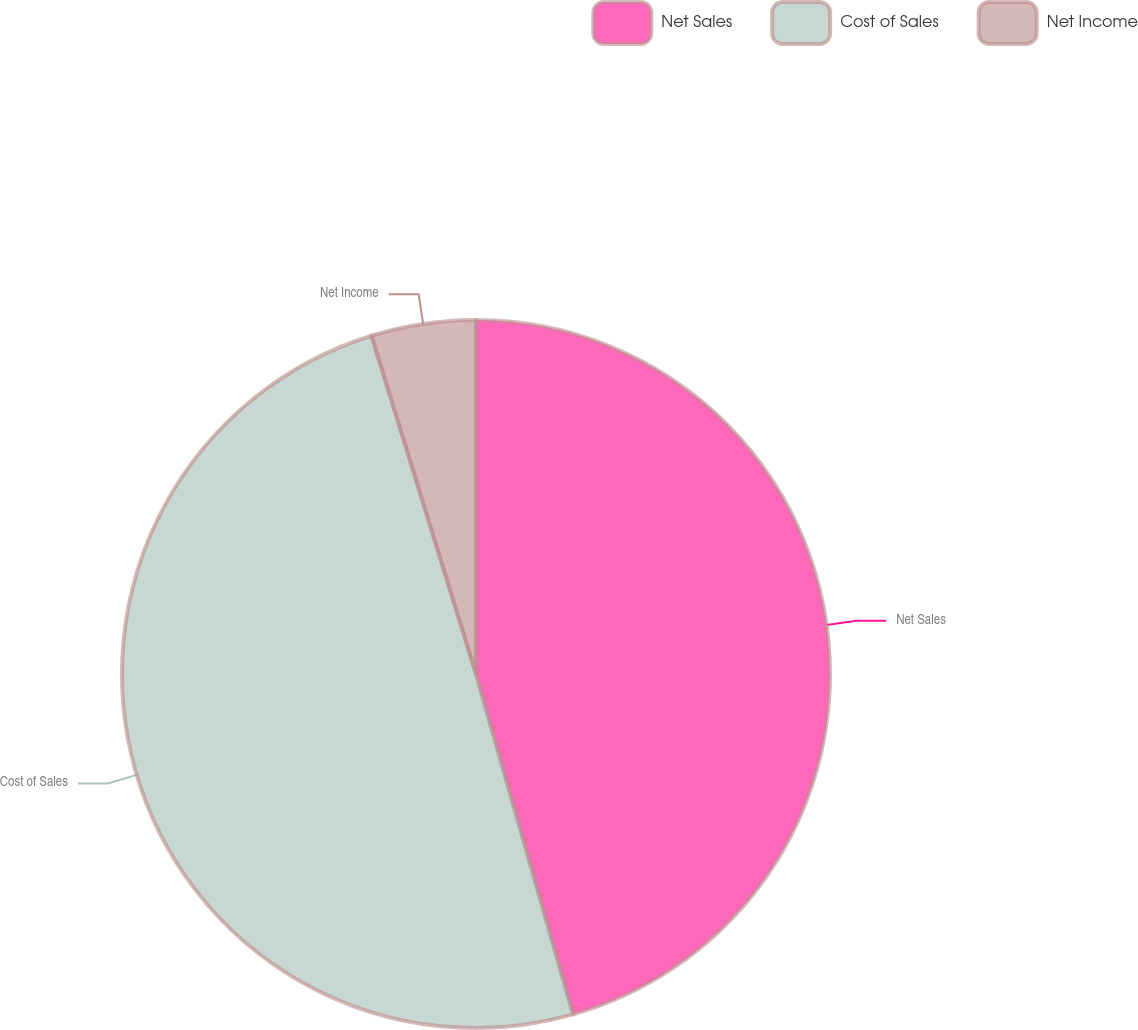<chart> <loc_0><loc_0><loc_500><loc_500><pie_chart><fcel>Net Sales<fcel>Cost of Sales<fcel>Net Income<nl><fcel>45.58%<fcel>49.66%<fcel>4.77%<nl></chart> 